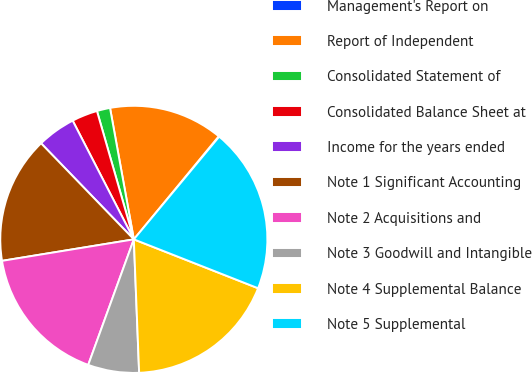Convert chart to OTSL. <chart><loc_0><loc_0><loc_500><loc_500><pie_chart><fcel>Management's Report on<fcel>Report of Independent<fcel>Consolidated Statement of<fcel>Consolidated Balance Sheet at<fcel>Income for the years ended<fcel>Note 1 Significant Accounting<fcel>Note 2 Acquisitions and<fcel>Note 3 Goodwill and Intangible<fcel>Note 4 Supplemental Balance<fcel>Note 5 Supplemental<nl><fcel>0.07%<fcel>13.82%<fcel>1.6%<fcel>3.12%<fcel>4.65%<fcel>15.35%<fcel>16.88%<fcel>6.18%<fcel>18.4%<fcel>19.93%<nl></chart> 